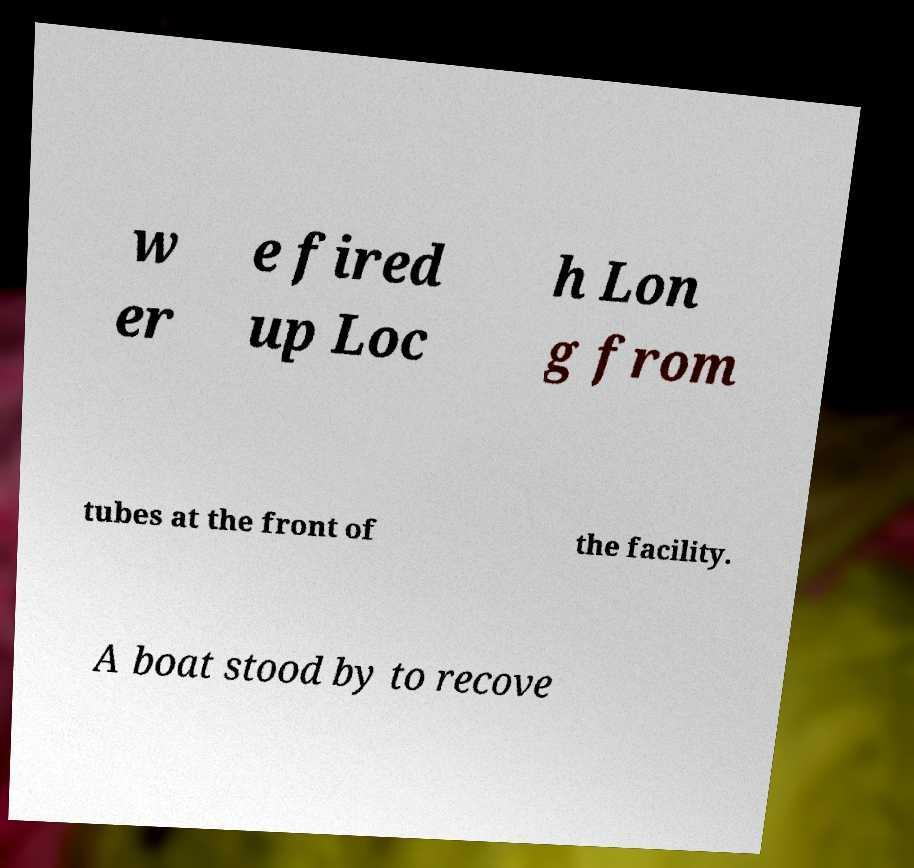Can you read and provide the text displayed in the image?This photo seems to have some interesting text. Can you extract and type it out for me? w er e fired up Loc h Lon g from tubes at the front of the facility. A boat stood by to recove 